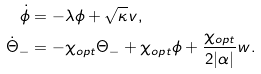Convert formula to latex. <formula><loc_0><loc_0><loc_500><loc_500>\dot { \phi } & = - \lambda \phi + \sqrt { \kappa } v , \\ \dot { \Theta } _ { - } & = - \chi _ { o p t } \Theta _ { - } + \chi _ { o p t } \phi + \frac { \chi _ { o p t } } { 2 | \alpha | } w .</formula> 